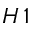Convert formula to latex. <formula><loc_0><loc_0><loc_500><loc_500>H \, 1</formula> 